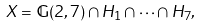Convert formula to latex. <formula><loc_0><loc_0><loc_500><loc_500>X = \mathbb { G } ( 2 , 7 ) \cap H _ { 1 } \cap \cdots \cap H _ { 7 } ,</formula> 